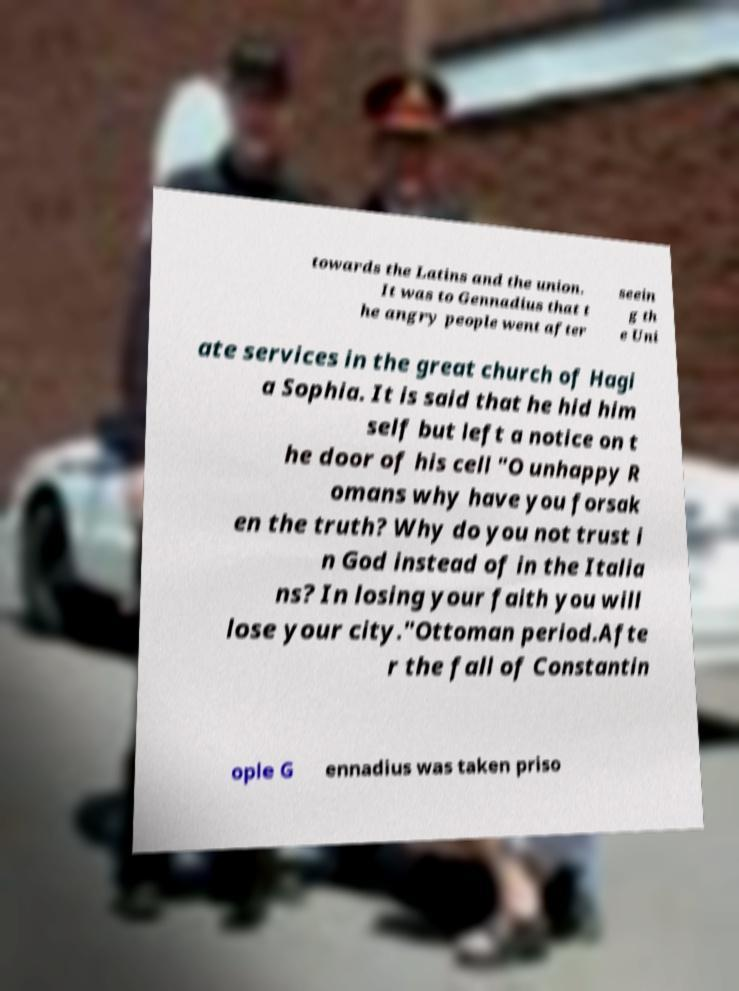Please identify and transcribe the text found in this image. towards the Latins and the union. It was to Gennadius that t he angry people went after seein g th e Uni ate services in the great church of Hagi a Sophia. It is said that he hid him self but left a notice on t he door of his cell "O unhappy R omans why have you forsak en the truth? Why do you not trust i n God instead of in the Italia ns? In losing your faith you will lose your city."Ottoman period.Afte r the fall of Constantin ople G ennadius was taken priso 